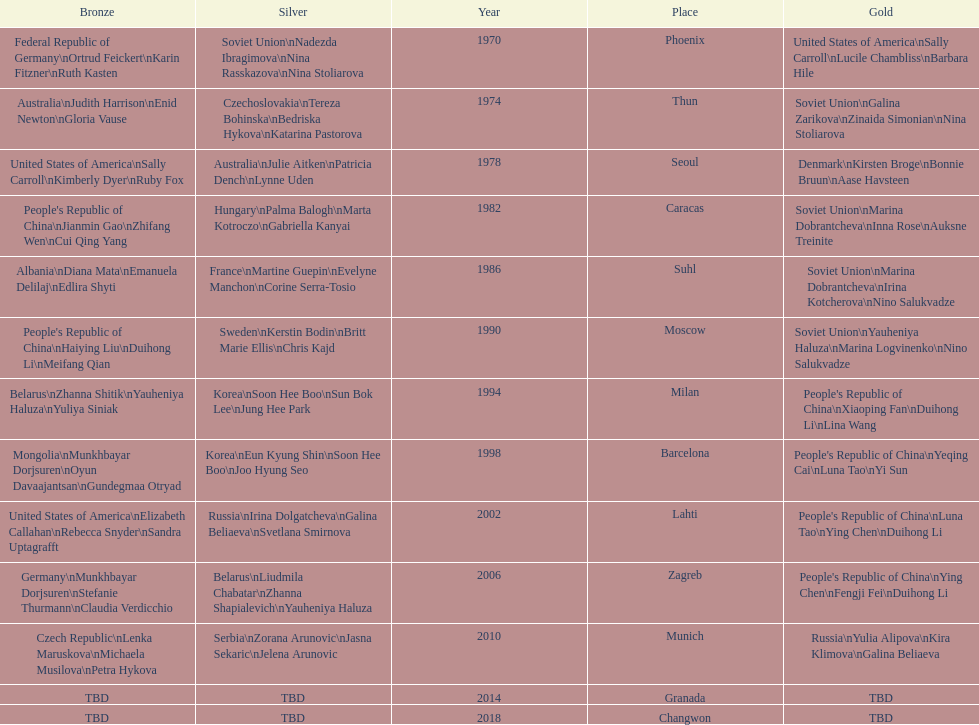What is the first place listed in this chart? Phoenix. 